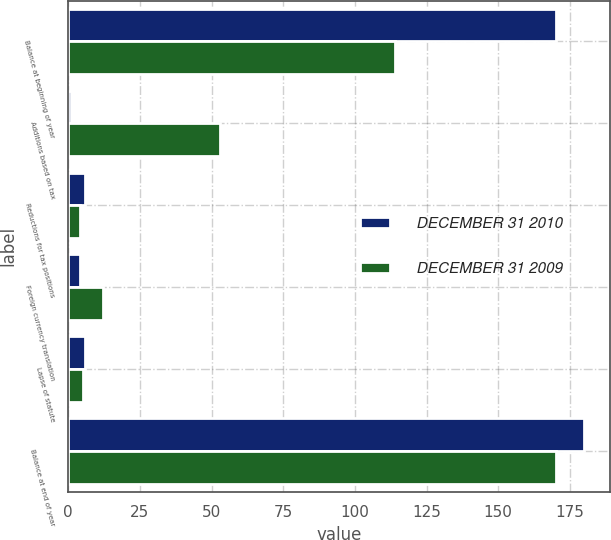Convert chart. <chart><loc_0><loc_0><loc_500><loc_500><stacked_bar_chart><ecel><fcel>Balance at beginning of year<fcel>Additions based on tax<fcel>Reductions for tax positions<fcel>Foreign currency translation<fcel>Lapse of statute<fcel>Balance at end of year<nl><fcel>DECEMBER 31 2010<fcel>170<fcel>1<fcel>6<fcel>4<fcel>6<fcel>180<nl><fcel>DECEMBER 31 2009<fcel>114<fcel>53<fcel>4<fcel>12<fcel>5<fcel>170<nl></chart> 